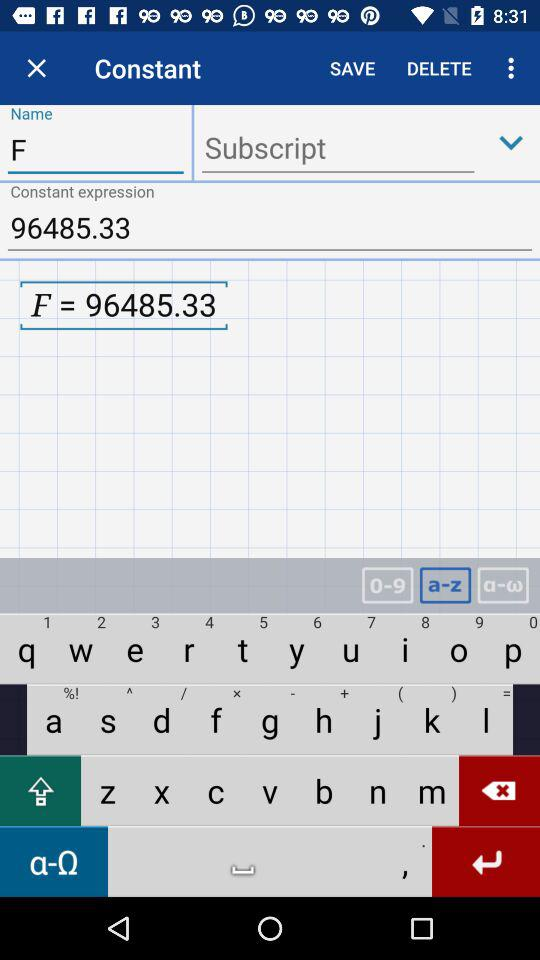What is the constant expression shown on the screen? The constant expression shown on the screen is 96485.33. 